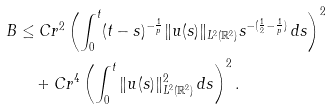Convert formula to latex. <formula><loc_0><loc_0><loc_500><loc_500>B & \leq C r ^ { 2 } \left ( \int _ { 0 } ^ { t } ( t - s ) ^ { - \frac { 1 } { p } } \| u ( s ) \| _ { L ^ { 2 } ( \mathbb { R } ^ { 2 } ) } s ^ { - ( \frac { 1 } { 2 } - \frac { 1 } { p } ) } \, d s \right ) ^ { 2 } \\ & \quad + C r ^ { 4 } \left ( \int _ { 0 } ^ { t } \| u ( s ) \| ^ { 2 } _ { L ^ { 2 } ( \mathbb { R } ^ { 2 } ) } \, d s \right ) ^ { 2 } .</formula> 